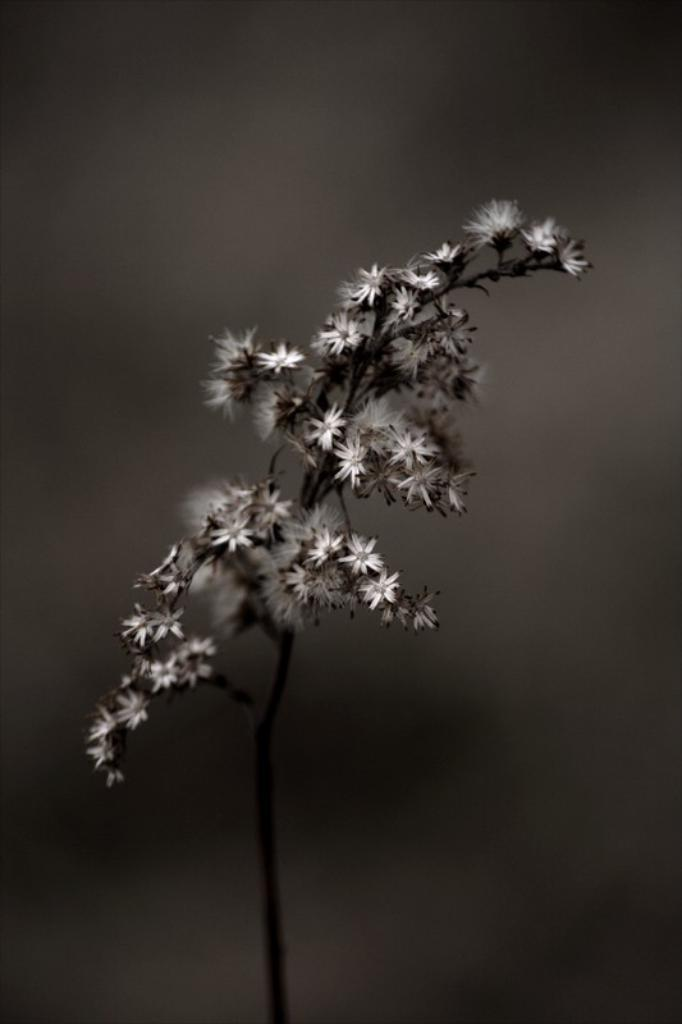What type of plant is visible in the image? There are flowers on a plant in the image. Can you describe the background of the image? The background of the image is blurry. What color scheme is used in the image? The image is black and white. What type of lunch is being served in the image? There is no lunch present in the image; it features a plant with flowers and a blurry background. Can you tell me what time it is based on the clock in the image? There is no clock present in the image. 